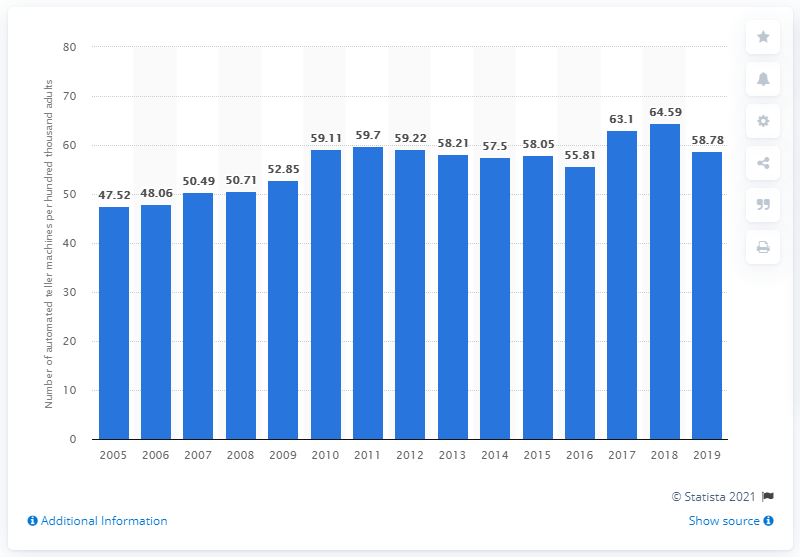Point out several critical features in this image. There were 58.78 ATMs in Singapore in 2019. 